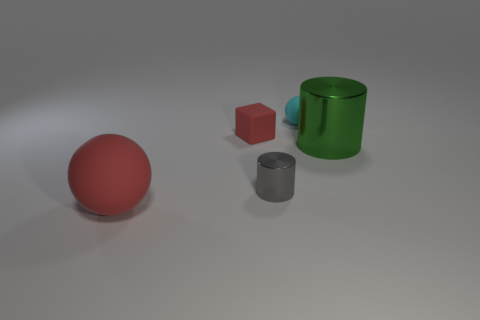Add 3 rubber blocks. How many objects exist? 8 Subtract all balls. How many objects are left? 3 Add 1 small matte objects. How many small matte objects are left? 3 Add 1 tiny cyan things. How many tiny cyan things exist? 2 Subtract 0 blue cylinders. How many objects are left? 5 Subtract all small purple blocks. Subtract all gray metal things. How many objects are left? 4 